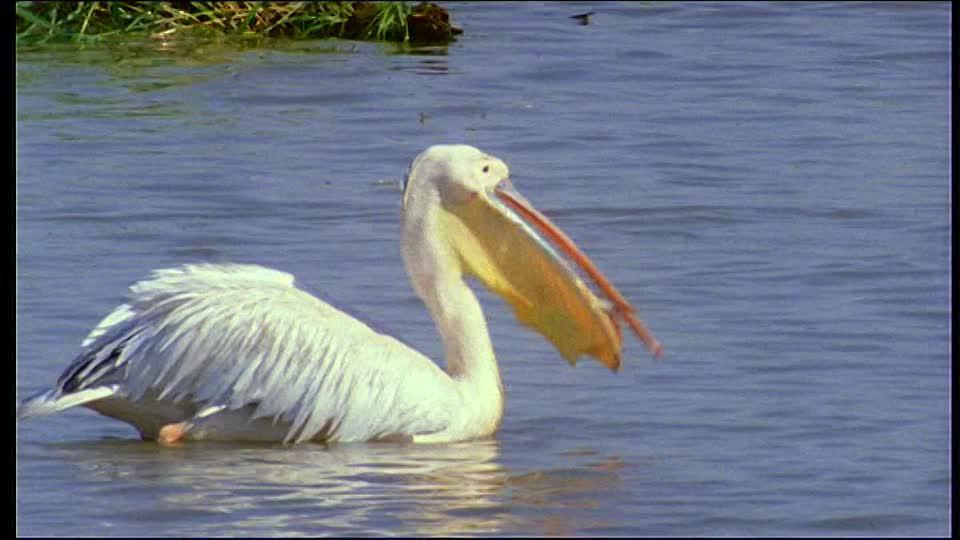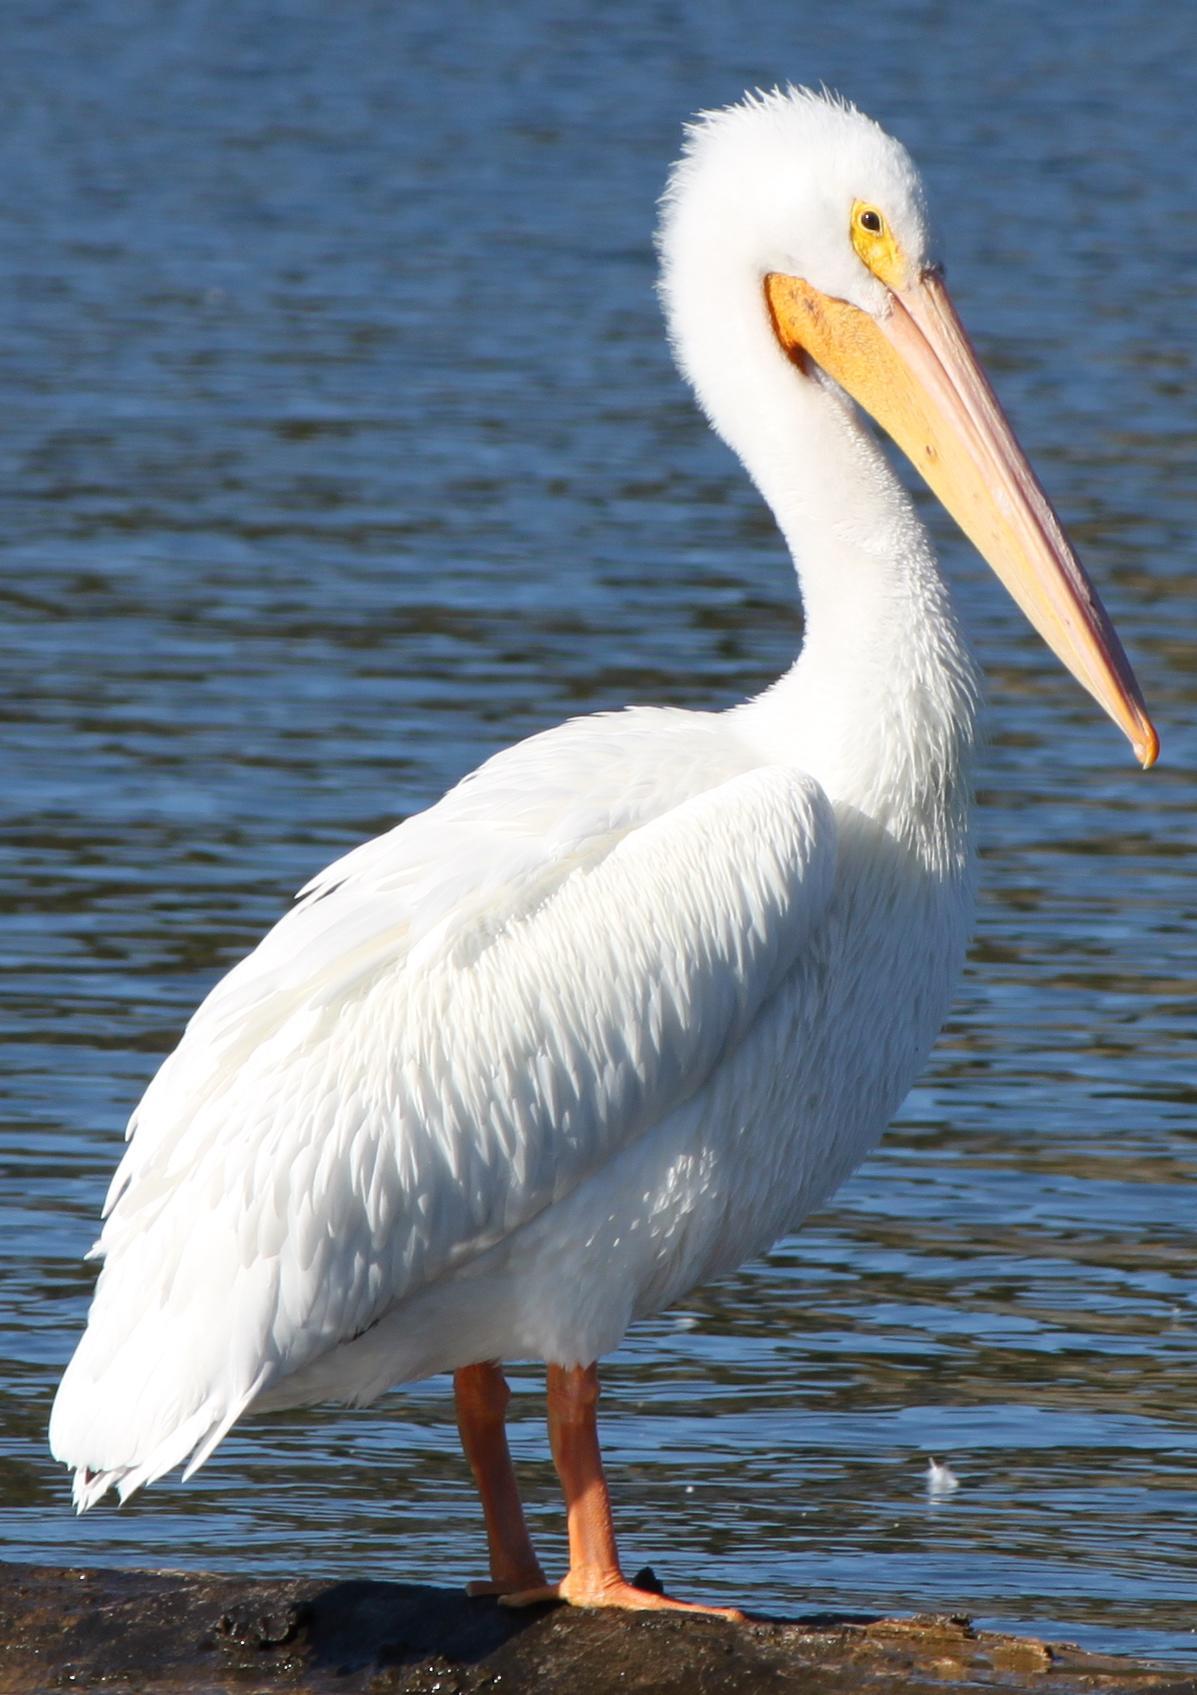The first image is the image on the left, the second image is the image on the right. Analyze the images presented: Is the assertion "At least one bird is standing, not swimming." valid? Answer yes or no. Yes. 